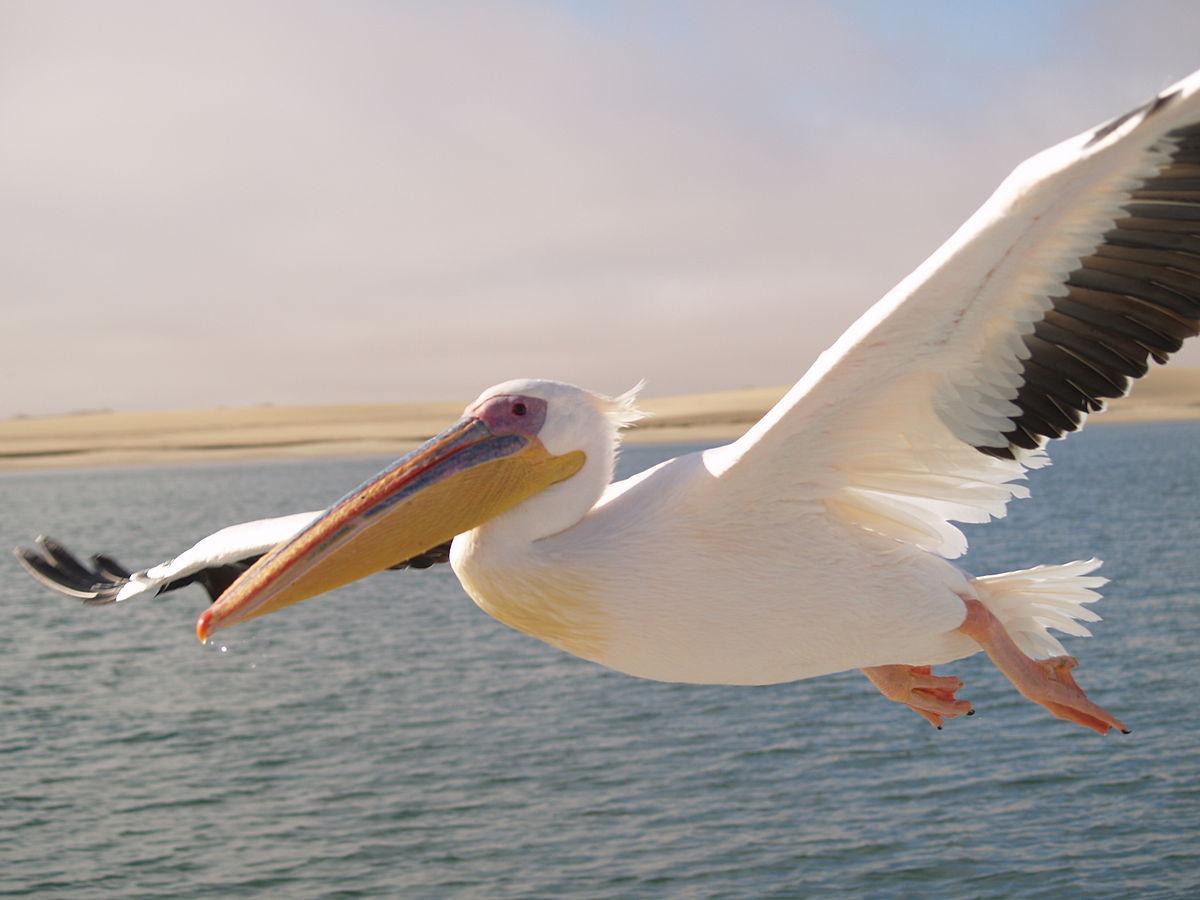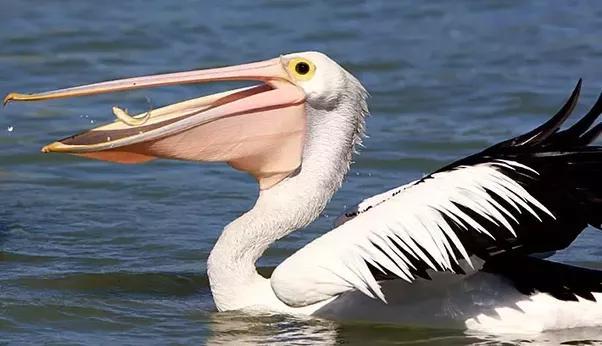The first image is the image on the left, the second image is the image on the right. Analyze the images presented: Is the assertion "The bird in the right image is facing towards the left." valid? Answer yes or no. Yes. The first image is the image on the left, the second image is the image on the right. Analyze the images presented: Is the assertion "A pelican with wings outstretched has an empty bill." valid? Answer yes or no. Yes. 